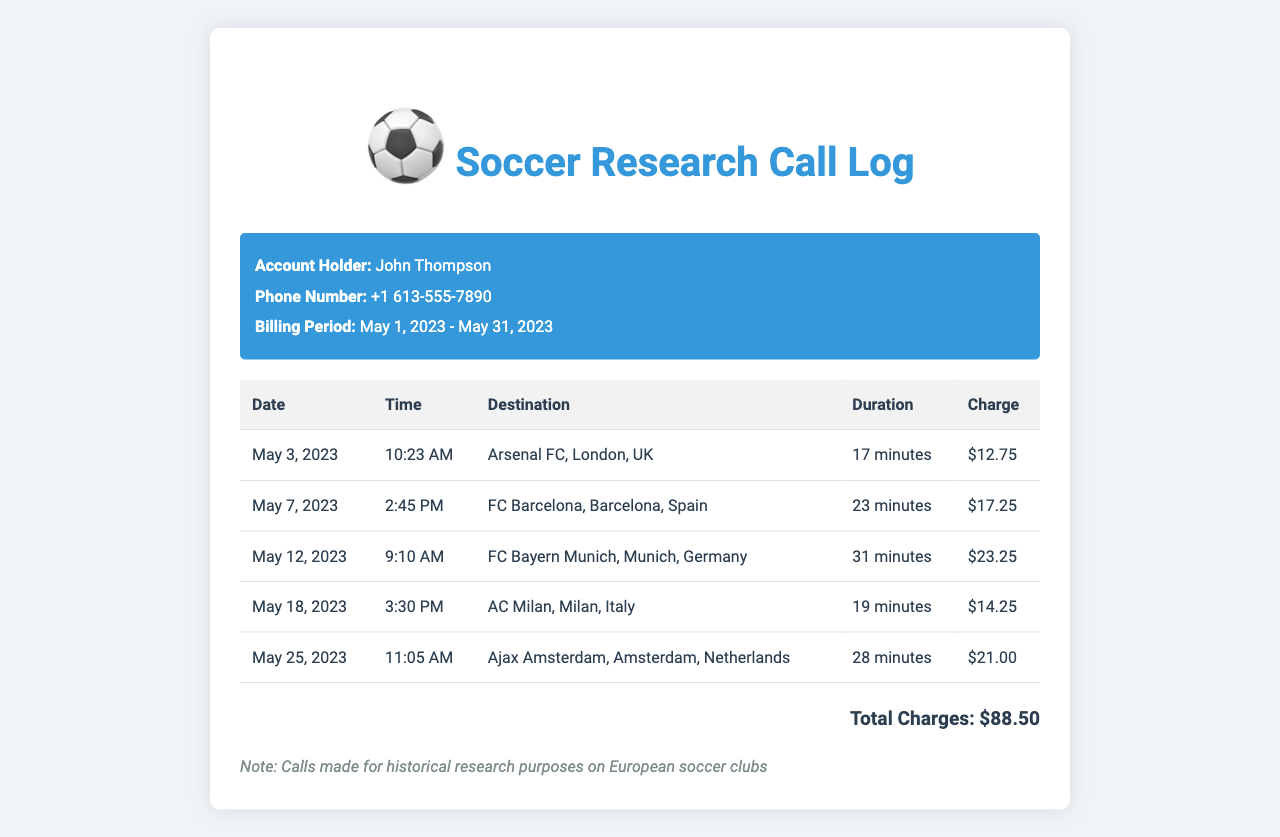What is the name of the account holder? The account holder's name is displayed at the top of the document.
Answer: John Thompson What is the phone number listed? The phone number is clearly stated in the header section of the document.
Answer: +1 613-555-7890 How many minutes was the longest call? The longest call duration can be found by comparing all entries in the duration column.
Answer: 31 minutes What was the charge for the call to FC Barcelona? The charge for the call to FC Barcelona can be found in the corresponding row of the table.
Answer: $17.25 What is the total amount charged for all calls? The total charges are summarized at the bottom of the document.
Answer: $88.50 Which club was called on May 12, 2023? The date and corresponding destination can be found in the table.
Answer: FC Bayern Munich Which country is Ajax Amsterdam located in? The destination row for Ajax Amsterdam includes the country information.
Answer: Netherlands How many calls were made in total? The number of rows in the table indicates the total calls made.
Answer: 5 What time was the call to AC Milan? The time for the call to AC Milan is specified in the relevant row of the table.
Answer: 3:30 PM What is the purpose of these calls? The note at the bottom of the document states the purpose of the calls.
Answer: Historical research purposes 